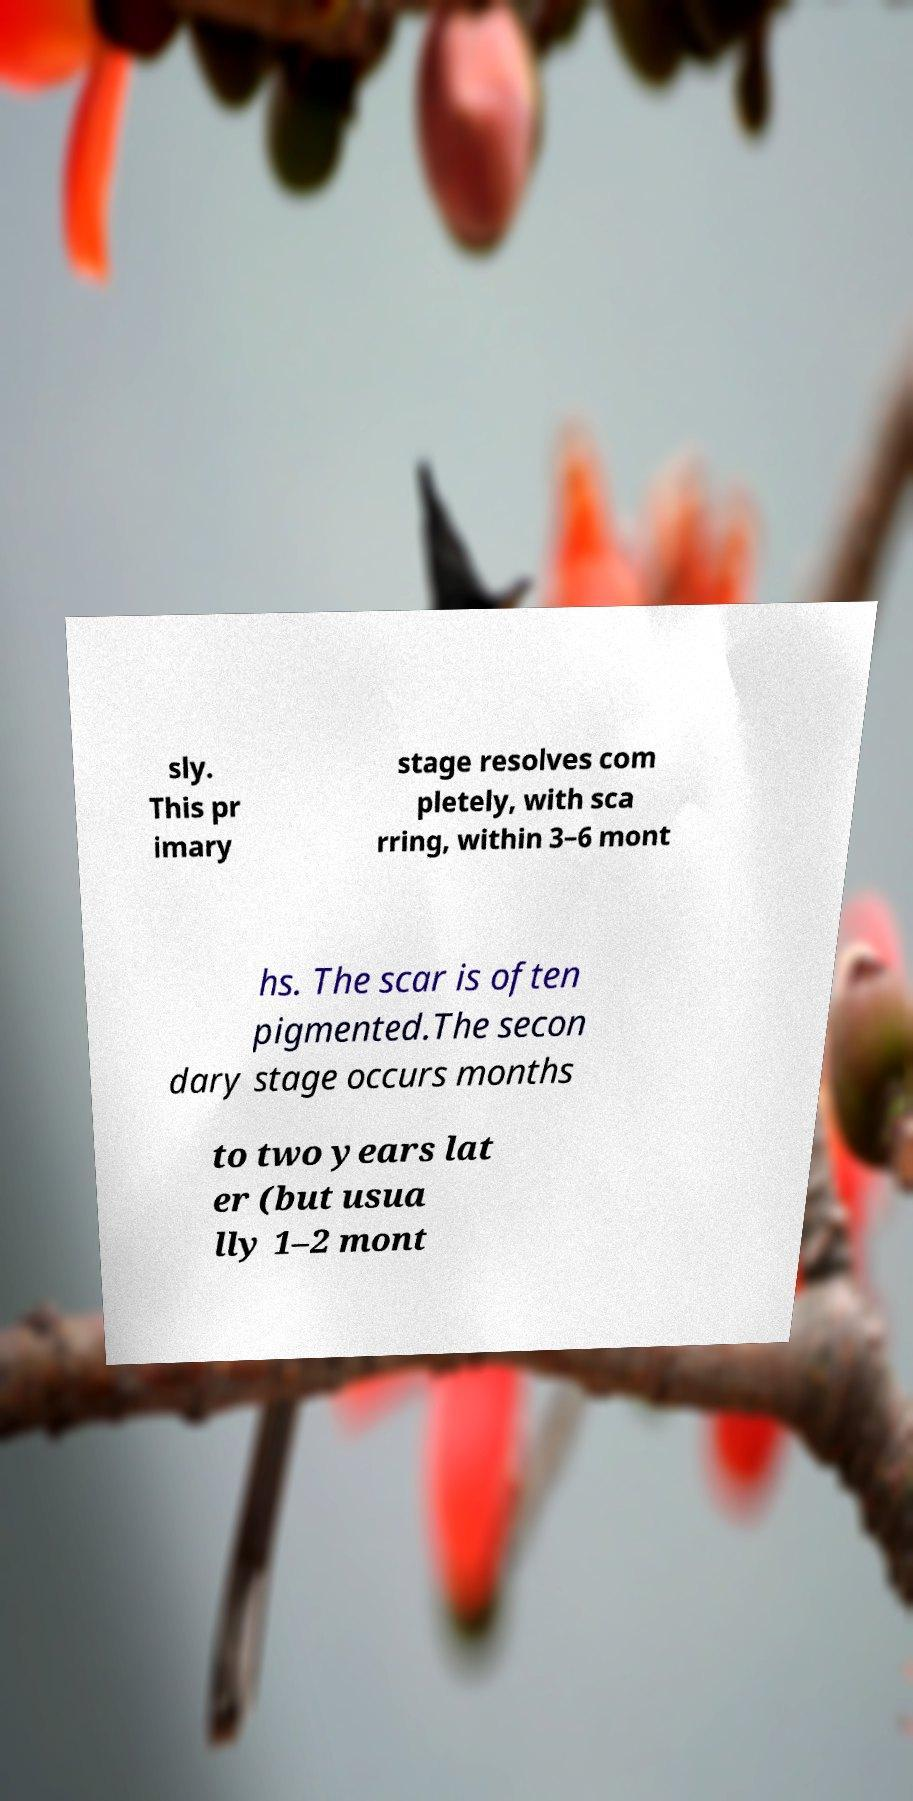Can you accurately transcribe the text from the provided image for me? sly. This pr imary stage resolves com pletely, with sca rring, within 3–6 mont hs. The scar is often pigmented.The secon dary stage occurs months to two years lat er (but usua lly 1–2 mont 